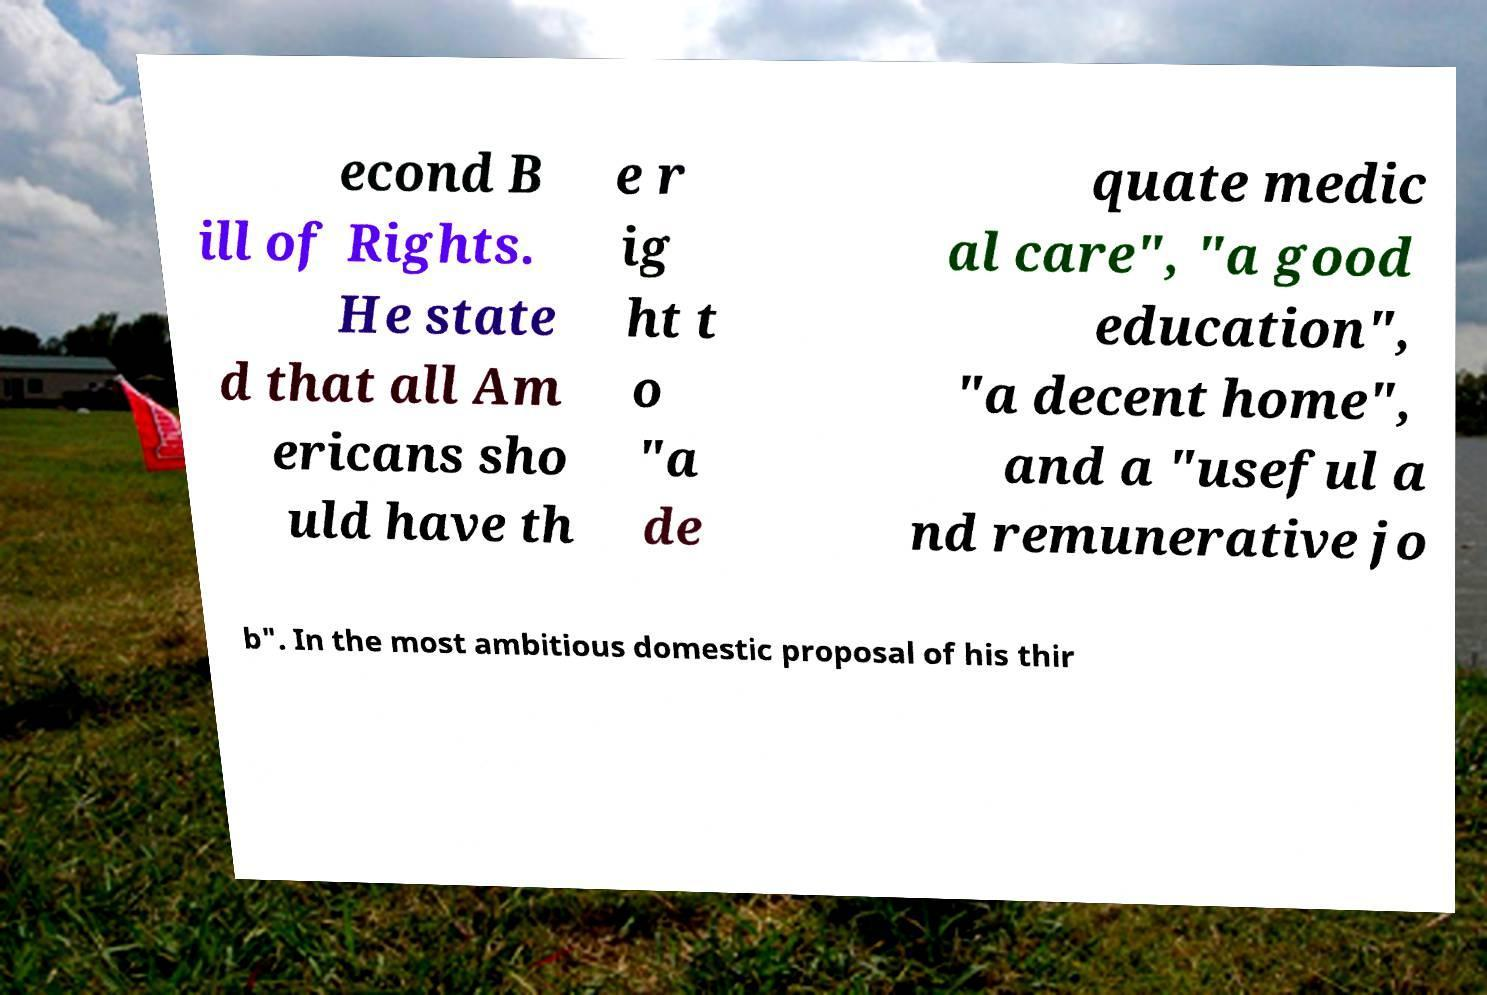Please identify and transcribe the text found in this image. econd B ill of Rights. He state d that all Am ericans sho uld have th e r ig ht t o "a de quate medic al care", "a good education", "a decent home", and a "useful a nd remunerative jo b". In the most ambitious domestic proposal of his thir 